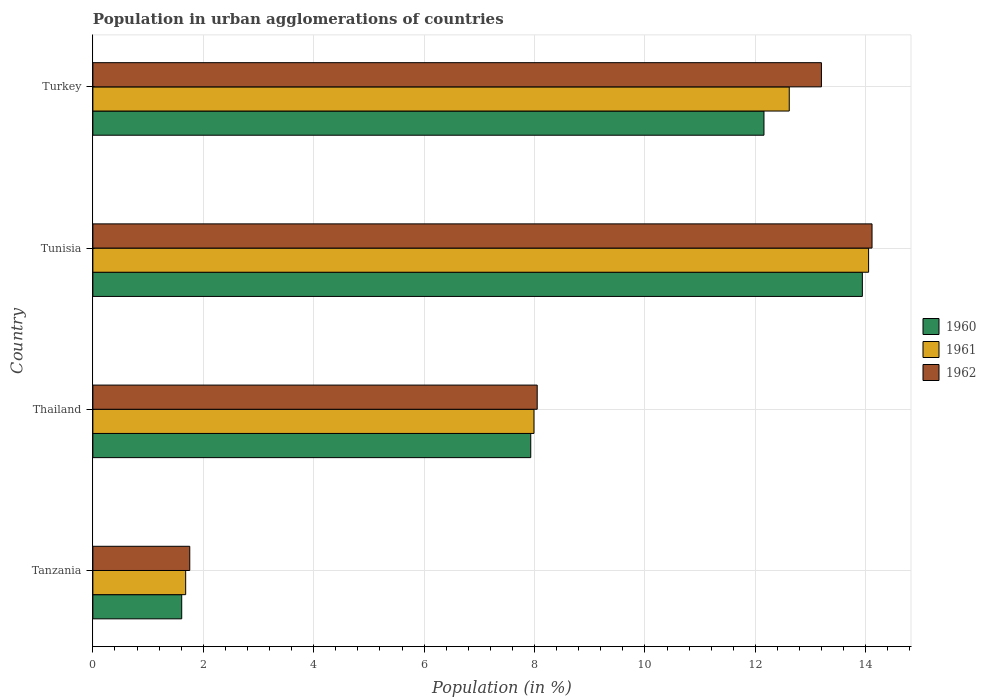How many groups of bars are there?
Ensure brevity in your answer.  4. Are the number of bars per tick equal to the number of legend labels?
Ensure brevity in your answer.  Yes. Are the number of bars on each tick of the Y-axis equal?
Offer a very short reply. Yes. How many bars are there on the 1st tick from the bottom?
Your response must be concise. 3. What is the percentage of population in urban agglomerations in 1960 in Tunisia?
Offer a terse response. 13.94. Across all countries, what is the maximum percentage of population in urban agglomerations in 1961?
Provide a succinct answer. 14.05. Across all countries, what is the minimum percentage of population in urban agglomerations in 1962?
Make the answer very short. 1.76. In which country was the percentage of population in urban agglomerations in 1960 maximum?
Your answer should be very brief. Tunisia. In which country was the percentage of population in urban agglomerations in 1960 minimum?
Offer a terse response. Tanzania. What is the total percentage of population in urban agglomerations in 1962 in the graph?
Keep it short and to the point. 37.11. What is the difference between the percentage of population in urban agglomerations in 1962 in Tanzania and that in Turkey?
Make the answer very short. -11.44. What is the difference between the percentage of population in urban agglomerations in 1960 in Thailand and the percentage of population in urban agglomerations in 1961 in Tanzania?
Offer a very short reply. 6.25. What is the average percentage of population in urban agglomerations in 1960 per country?
Your answer should be very brief. 8.91. What is the difference between the percentage of population in urban agglomerations in 1962 and percentage of population in urban agglomerations in 1960 in Tanzania?
Keep it short and to the point. 0.15. What is the ratio of the percentage of population in urban agglomerations in 1960 in Tanzania to that in Tunisia?
Offer a terse response. 0.12. What is the difference between the highest and the second highest percentage of population in urban agglomerations in 1960?
Offer a very short reply. 1.78. What is the difference between the highest and the lowest percentage of population in urban agglomerations in 1960?
Your answer should be very brief. 12.33. In how many countries, is the percentage of population in urban agglomerations in 1961 greater than the average percentage of population in urban agglomerations in 1961 taken over all countries?
Your answer should be very brief. 2. Is the sum of the percentage of population in urban agglomerations in 1960 in Tanzania and Turkey greater than the maximum percentage of population in urban agglomerations in 1961 across all countries?
Provide a succinct answer. No. What does the 1st bar from the top in Thailand represents?
Ensure brevity in your answer.  1962. How many bars are there?
Offer a very short reply. 12. Are all the bars in the graph horizontal?
Offer a terse response. Yes. Does the graph contain grids?
Give a very brief answer. Yes. Where does the legend appear in the graph?
Your answer should be compact. Center right. How many legend labels are there?
Make the answer very short. 3. How are the legend labels stacked?
Ensure brevity in your answer.  Vertical. What is the title of the graph?
Ensure brevity in your answer.  Population in urban agglomerations of countries. What is the label or title of the X-axis?
Provide a succinct answer. Population (in %). What is the Population (in %) in 1960 in Tanzania?
Keep it short and to the point. 1.61. What is the Population (in %) in 1961 in Tanzania?
Offer a terse response. 1.68. What is the Population (in %) of 1962 in Tanzania?
Ensure brevity in your answer.  1.76. What is the Population (in %) in 1960 in Thailand?
Provide a succinct answer. 7.93. What is the Population (in %) of 1961 in Thailand?
Give a very brief answer. 7.99. What is the Population (in %) of 1962 in Thailand?
Your response must be concise. 8.05. What is the Population (in %) in 1960 in Tunisia?
Offer a terse response. 13.94. What is the Population (in %) of 1961 in Tunisia?
Your answer should be compact. 14.05. What is the Population (in %) of 1962 in Tunisia?
Ensure brevity in your answer.  14.11. What is the Population (in %) of 1960 in Turkey?
Provide a succinct answer. 12.16. What is the Population (in %) in 1961 in Turkey?
Offer a terse response. 12.61. What is the Population (in %) in 1962 in Turkey?
Offer a terse response. 13.2. Across all countries, what is the maximum Population (in %) in 1960?
Give a very brief answer. 13.94. Across all countries, what is the maximum Population (in %) in 1961?
Make the answer very short. 14.05. Across all countries, what is the maximum Population (in %) of 1962?
Your answer should be compact. 14.11. Across all countries, what is the minimum Population (in %) in 1960?
Ensure brevity in your answer.  1.61. Across all countries, what is the minimum Population (in %) of 1961?
Your answer should be compact. 1.68. Across all countries, what is the minimum Population (in %) of 1962?
Ensure brevity in your answer.  1.76. What is the total Population (in %) in 1960 in the graph?
Give a very brief answer. 35.63. What is the total Population (in %) in 1961 in the graph?
Your answer should be very brief. 36.34. What is the total Population (in %) in 1962 in the graph?
Ensure brevity in your answer.  37.11. What is the difference between the Population (in %) of 1960 in Tanzania and that in Thailand?
Make the answer very short. -6.32. What is the difference between the Population (in %) in 1961 in Tanzania and that in Thailand?
Offer a very short reply. -6.31. What is the difference between the Population (in %) of 1962 in Tanzania and that in Thailand?
Ensure brevity in your answer.  -6.29. What is the difference between the Population (in %) of 1960 in Tanzania and that in Tunisia?
Provide a short and direct response. -12.33. What is the difference between the Population (in %) in 1961 in Tanzania and that in Tunisia?
Your answer should be compact. -12.37. What is the difference between the Population (in %) in 1962 in Tanzania and that in Tunisia?
Ensure brevity in your answer.  -12.36. What is the difference between the Population (in %) of 1960 in Tanzania and that in Turkey?
Provide a succinct answer. -10.55. What is the difference between the Population (in %) of 1961 in Tanzania and that in Turkey?
Your answer should be compact. -10.93. What is the difference between the Population (in %) in 1962 in Tanzania and that in Turkey?
Offer a very short reply. -11.44. What is the difference between the Population (in %) of 1960 in Thailand and that in Tunisia?
Give a very brief answer. -6.01. What is the difference between the Population (in %) in 1961 in Thailand and that in Tunisia?
Your answer should be very brief. -6.06. What is the difference between the Population (in %) of 1962 in Thailand and that in Tunisia?
Make the answer very short. -6.07. What is the difference between the Population (in %) in 1960 in Thailand and that in Turkey?
Give a very brief answer. -4.22. What is the difference between the Population (in %) of 1961 in Thailand and that in Turkey?
Your response must be concise. -4.62. What is the difference between the Population (in %) of 1962 in Thailand and that in Turkey?
Your response must be concise. -5.15. What is the difference between the Population (in %) of 1960 in Tunisia and that in Turkey?
Your response must be concise. 1.78. What is the difference between the Population (in %) in 1961 in Tunisia and that in Turkey?
Make the answer very short. 1.44. What is the difference between the Population (in %) in 1960 in Tanzania and the Population (in %) in 1961 in Thailand?
Provide a short and direct response. -6.38. What is the difference between the Population (in %) of 1960 in Tanzania and the Population (in %) of 1962 in Thailand?
Provide a short and direct response. -6.44. What is the difference between the Population (in %) in 1961 in Tanzania and the Population (in %) in 1962 in Thailand?
Your answer should be very brief. -6.37. What is the difference between the Population (in %) of 1960 in Tanzania and the Population (in %) of 1961 in Tunisia?
Make the answer very short. -12.44. What is the difference between the Population (in %) of 1960 in Tanzania and the Population (in %) of 1962 in Tunisia?
Provide a short and direct response. -12.5. What is the difference between the Population (in %) of 1961 in Tanzania and the Population (in %) of 1962 in Tunisia?
Keep it short and to the point. -12.43. What is the difference between the Population (in %) of 1960 in Tanzania and the Population (in %) of 1961 in Turkey?
Provide a short and direct response. -11. What is the difference between the Population (in %) of 1960 in Tanzania and the Population (in %) of 1962 in Turkey?
Ensure brevity in your answer.  -11.59. What is the difference between the Population (in %) in 1961 in Tanzania and the Population (in %) in 1962 in Turkey?
Keep it short and to the point. -11.52. What is the difference between the Population (in %) in 1960 in Thailand and the Population (in %) in 1961 in Tunisia?
Make the answer very short. -6.12. What is the difference between the Population (in %) of 1960 in Thailand and the Population (in %) of 1962 in Tunisia?
Offer a terse response. -6.18. What is the difference between the Population (in %) in 1961 in Thailand and the Population (in %) in 1962 in Tunisia?
Keep it short and to the point. -6.12. What is the difference between the Population (in %) of 1960 in Thailand and the Population (in %) of 1961 in Turkey?
Give a very brief answer. -4.68. What is the difference between the Population (in %) in 1960 in Thailand and the Population (in %) in 1962 in Turkey?
Ensure brevity in your answer.  -5.27. What is the difference between the Population (in %) of 1961 in Thailand and the Population (in %) of 1962 in Turkey?
Keep it short and to the point. -5.21. What is the difference between the Population (in %) in 1960 in Tunisia and the Population (in %) in 1961 in Turkey?
Your answer should be very brief. 1.32. What is the difference between the Population (in %) in 1960 in Tunisia and the Population (in %) in 1962 in Turkey?
Make the answer very short. 0.74. What is the difference between the Population (in %) in 1961 in Tunisia and the Population (in %) in 1962 in Turkey?
Give a very brief answer. 0.85. What is the average Population (in %) of 1960 per country?
Give a very brief answer. 8.91. What is the average Population (in %) of 1961 per country?
Make the answer very short. 9.08. What is the average Population (in %) of 1962 per country?
Your response must be concise. 9.28. What is the difference between the Population (in %) in 1960 and Population (in %) in 1961 in Tanzania?
Make the answer very short. -0.07. What is the difference between the Population (in %) of 1960 and Population (in %) of 1962 in Tanzania?
Your answer should be very brief. -0.15. What is the difference between the Population (in %) in 1961 and Population (in %) in 1962 in Tanzania?
Offer a terse response. -0.07. What is the difference between the Population (in %) of 1960 and Population (in %) of 1961 in Thailand?
Provide a short and direct response. -0.06. What is the difference between the Population (in %) in 1960 and Population (in %) in 1962 in Thailand?
Offer a terse response. -0.12. What is the difference between the Population (in %) in 1961 and Population (in %) in 1962 in Thailand?
Ensure brevity in your answer.  -0.06. What is the difference between the Population (in %) in 1960 and Population (in %) in 1961 in Tunisia?
Your answer should be compact. -0.11. What is the difference between the Population (in %) of 1960 and Population (in %) of 1962 in Tunisia?
Provide a short and direct response. -0.18. What is the difference between the Population (in %) of 1961 and Population (in %) of 1962 in Tunisia?
Provide a succinct answer. -0.06. What is the difference between the Population (in %) of 1960 and Population (in %) of 1961 in Turkey?
Make the answer very short. -0.46. What is the difference between the Population (in %) in 1960 and Population (in %) in 1962 in Turkey?
Provide a succinct answer. -1.04. What is the difference between the Population (in %) of 1961 and Population (in %) of 1962 in Turkey?
Give a very brief answer. -0.58. What is the ratio of the Population (in %) of 1960 in Tanzania to that in Thailand?
Your answer should be very brief. 0.2. What is the ratio of the Population (in %) of 1961 in Tanzania to that in Thailand?
Your answer should be compact. 0.21. What is the ratio of the Population (in %) of 1962 in Tanzania to that in Thailand?
Offer a very short reply. 0.22. What is the ratio of the Population (in %) of 1960 in Tanzania to that in Tunisia?
Provide a succinct answer. 0.12. What is the ratio of the Population (in %) in 1961 in Tanzania to that in Tunisia?
Offer a very short reply. 0.12. What is the ratio of the Population (in %) in 1962 in Tanzania to that in Tunisia?
Ensure brevity in your answer.  0.12. What is the ratio of the Population (in %) in 1960 in Tanzania to that in Turkey?
Your response must be concise. 0.13. What is the ratio of the Population (in %) of 1961 in Tanzania to that in Turkey?
Offer a very short reply. 0.13. What is the ratio of the Population (in %) of 1962 in Tanzania to that in Turkey?
Offer a terse response. 0.13. What is the ratio of the Population (in %) of 1960 in Thailand to that in Tunisia?
Provide a succinct answer. 0.57. What is the ratio of the Population (in %) of 1961 in Thailand to that in Tunisia?
Ensure brevity in your answer.  0.57. What is the ratio of the Population (in %) of 1962 in Thailand to that in Tunisia?
Give a very brief answer. 0.57. What is the ratio of the Population (in %) in 1960 in Thailand to that in Turkey?
Your answer should be very brief. 0.65. What is the ratio of the Population (in %) in 1961 in Thailand to that in Turkey?
Offer a terse response. 0.63. What is the ratio of the Population (in %) in 1962 in Thailand to that in Turkey?
Your answer should be compact. 0.61. What is the ratio of the Population (in %) in 1960 in Tunisia to that in Turkey?
Provide a short and direct response. 1.15. What is the ratio of the Population (in %) of 1961 in Tunisia to that in Turkey?
Make the answer very short. 1.11. What is the ratio of the Population (in %) of 1962 in Tunisia to that in Turkey?
Your answer should be compact. 1.07. What is the difference between the highest and the second highest Population (in %) of 1960?
Give a very brief answer. 1.78. What is the difference between the highest and the second highest Population (in %) in 1961?
Offer a terse response. 1.44. What is the difference between the highest and the second highest Population (in %) in 1962?
Offer a very short reply. 0.92. What is the difference between the highest and the lowest Population (in %) in 1960?
Keep it short and to the point. 12.33. What is the difference between the highest and the lowest Population (in %) of 1961?
Make the answer very short. 12.37. What is the difference between the highest and the lowest Population (in %) of 1962?
Offer a terse response. 12.36. 